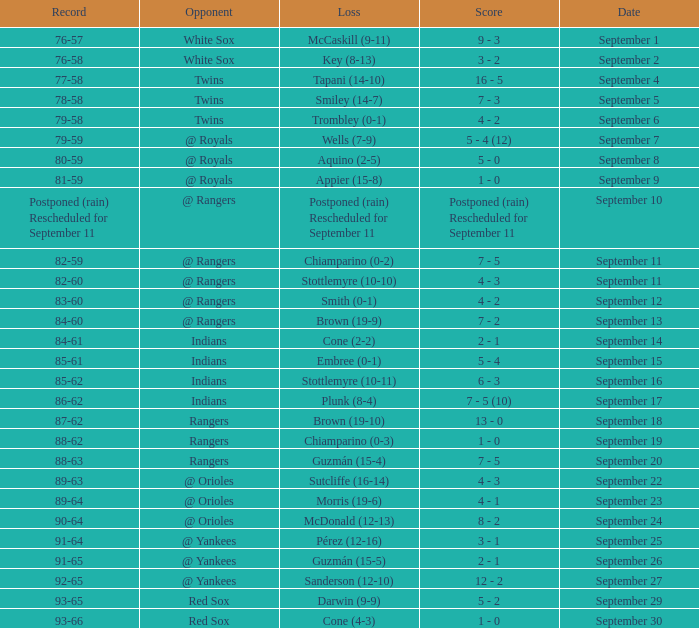What opponent has a loss of McCaskill (9-11)? White Sox. 